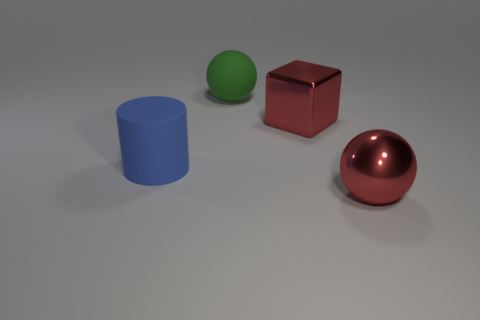Add 2 green balls. How many objects exist? 6 Add 3 large blue matte cylinders. How many large blue matte cylinders are left? 4 Add 3 small cyan things. How many small cyan things exist? 3 Subtract 1 red blocks. How many objects are left? 3 Subtract all green objects. Subtract all red metal spheres. How many objects are left? 2 